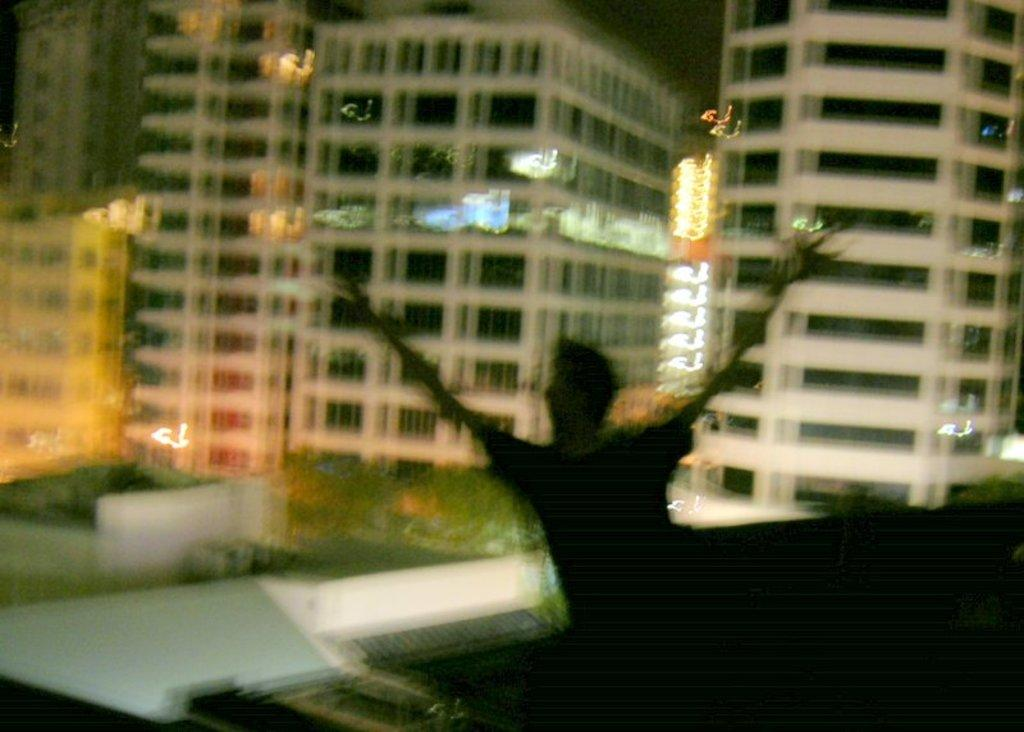Who or what is present in the image? There is a person in the image. What type of structure can be seen in the image? There is a building with windows in the image. How would you describe the sky in the image? The sky is dark in the image. What type of vessel is being used for the feast in the image? There is no vessel or feast present in the image. Can you tell me where the club is located in the image? There is no club present in the image. 